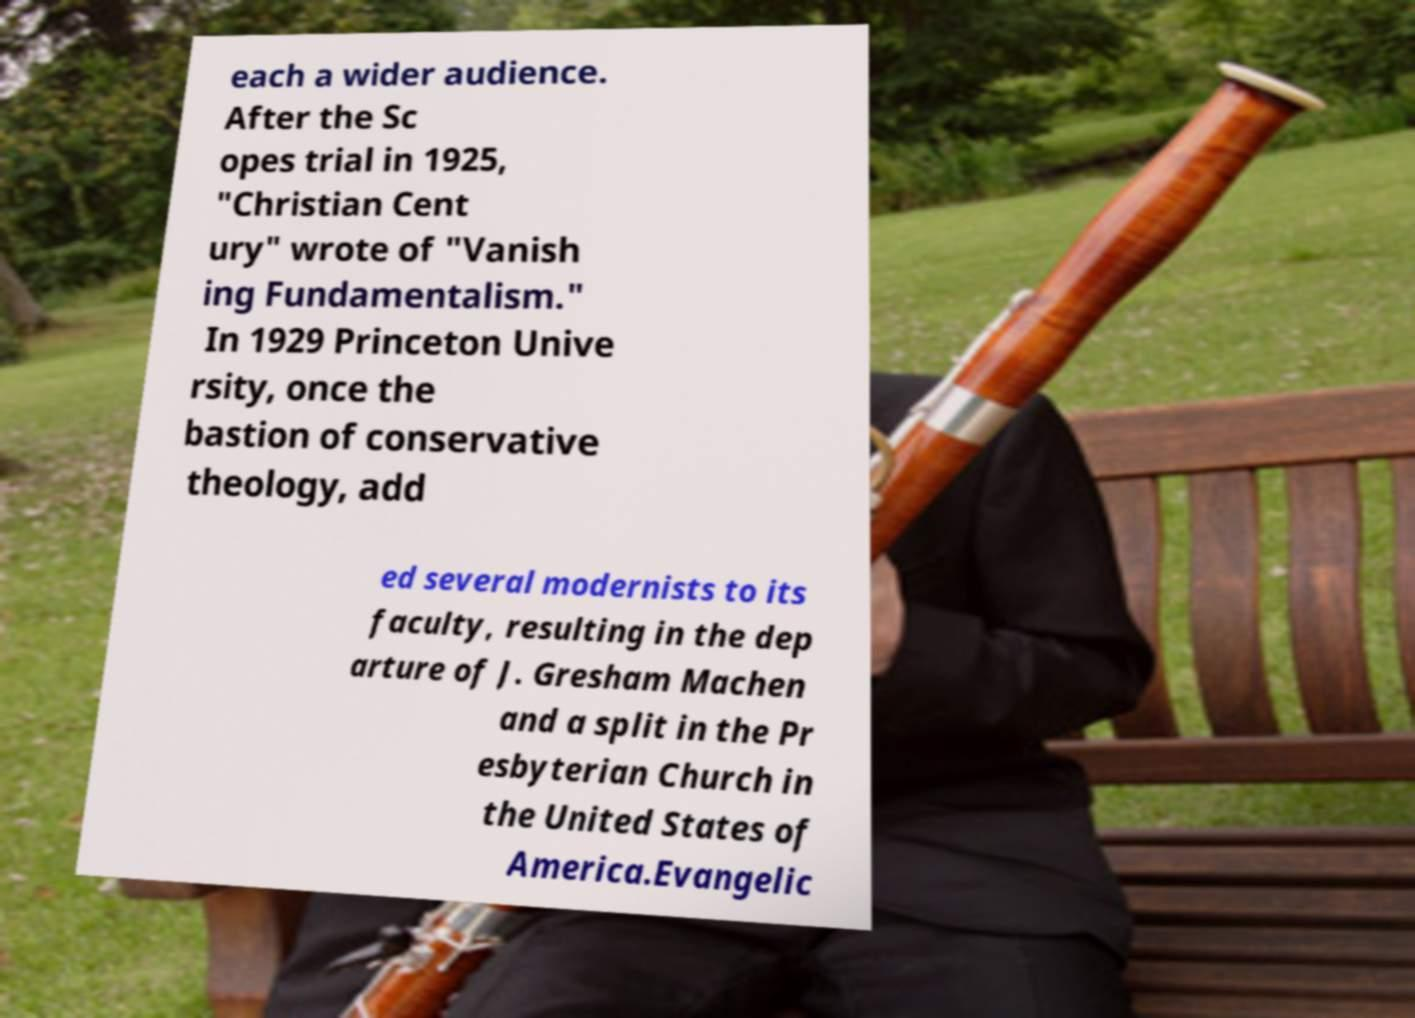Can you accurately transcribe the text from the provided image for me? each a wider audience. After the Sc opes trial in 1925, "Christian Cent ury" wrote of "Vanish ing Fundamentalism." In 1929 Princeton Unive rsity, once the bastion of conservative theology, add ed several modernists to its faculty, resulting in the dep arture of J. Gresham Machen and a split in the Pr esbyterian Church in the United States of America.Evangelic 